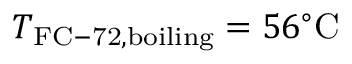Convert formula to latex. <formula><loc_0><loc_0><loc_500><loc_500>T _ { F C - 7 2 , b o i l i n g } = 5 6 ^ { \circ } C</formula> 